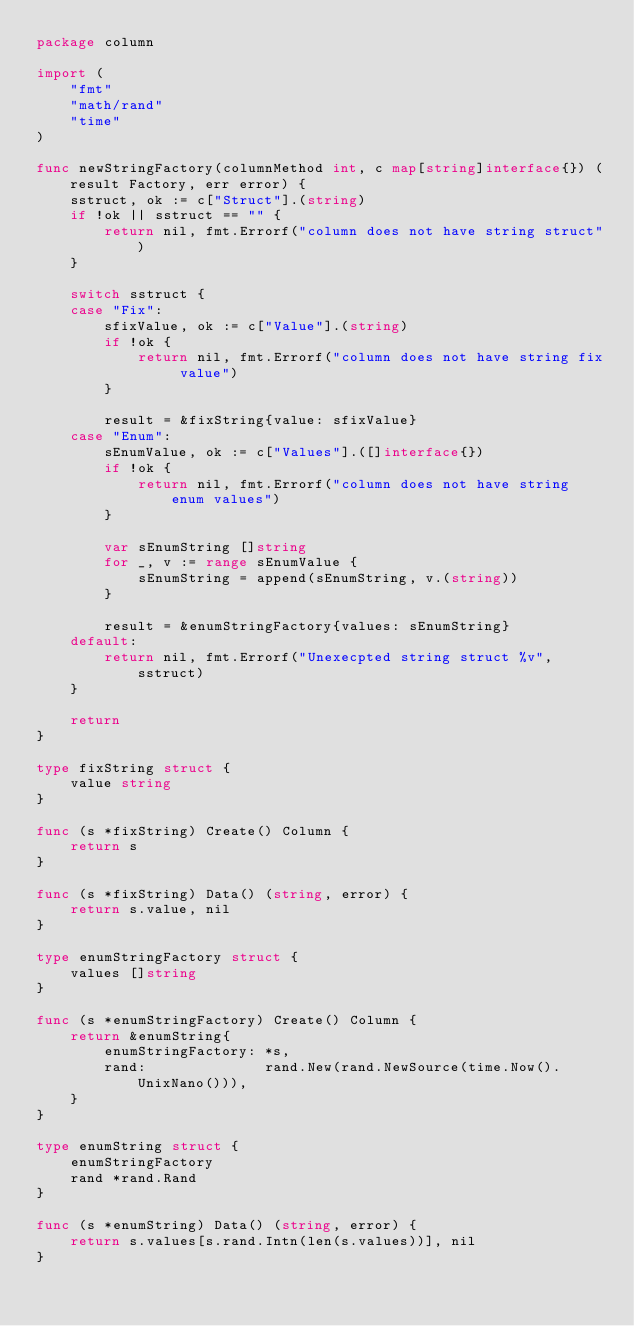<code> <loc_0><loc_0><loc_500><loc_500><_Go_>package column

import (
	"fmt"
	"math/rand"
	"time"
)

func newStringFactory(columnMethod int, c map[string]interface{}) (result Factory, err error) {
	sstruct, ok := c["Struct"].(string)
	if !ok || sstruct == "" {
		return nil, fmt.Errorf("column does not have string struct")
	}

	switch sstruct {
	case "Fix":
		sfixValue, ok := c["Value"].(string)
		if !ok {
			return nil, fmt.Errorf("column does not have string fix value")
		}

		result = &fixString{value: sfixValue}
	case "Enum":
		sEnumValue, ok := c["Values"].([]interface{})
		if !ok {
			return nil, fmt.Errorf("column does not have string enum values")
		}

		var sEnumString []string
		for _, v := range sEnumValue {
			sEnumString = append(sEnumString, v.(string))
		}

		result = &enumStringFactory{values: sEnumString}
	default:
		return nil, fmt.Errorf("Unexecpted string struct %v", sstruct)
	}

	return
}

type fixString struct {
	value string
}

func (s *fixString) Create() Column {
	return s
}

func (s *fixString) Data() (string, error) {
	return s.value, nil
}

type enumStringFactory struct {
	values []string
}

func (s *enumStringFactory) Create() Column {
	return &enumString{
		enumStringFactory: *s,
		rand:              rand.New(rand.NewSource(time.Now().UnixNano())),
	}
}

type enumString struct {
	enumStringFactory
	rand *rand.Rand
}

func (s *enumString) Data() (string, error) {
	return s.values[s.rand.Intn(len(s.values))], nil
}
</code> 